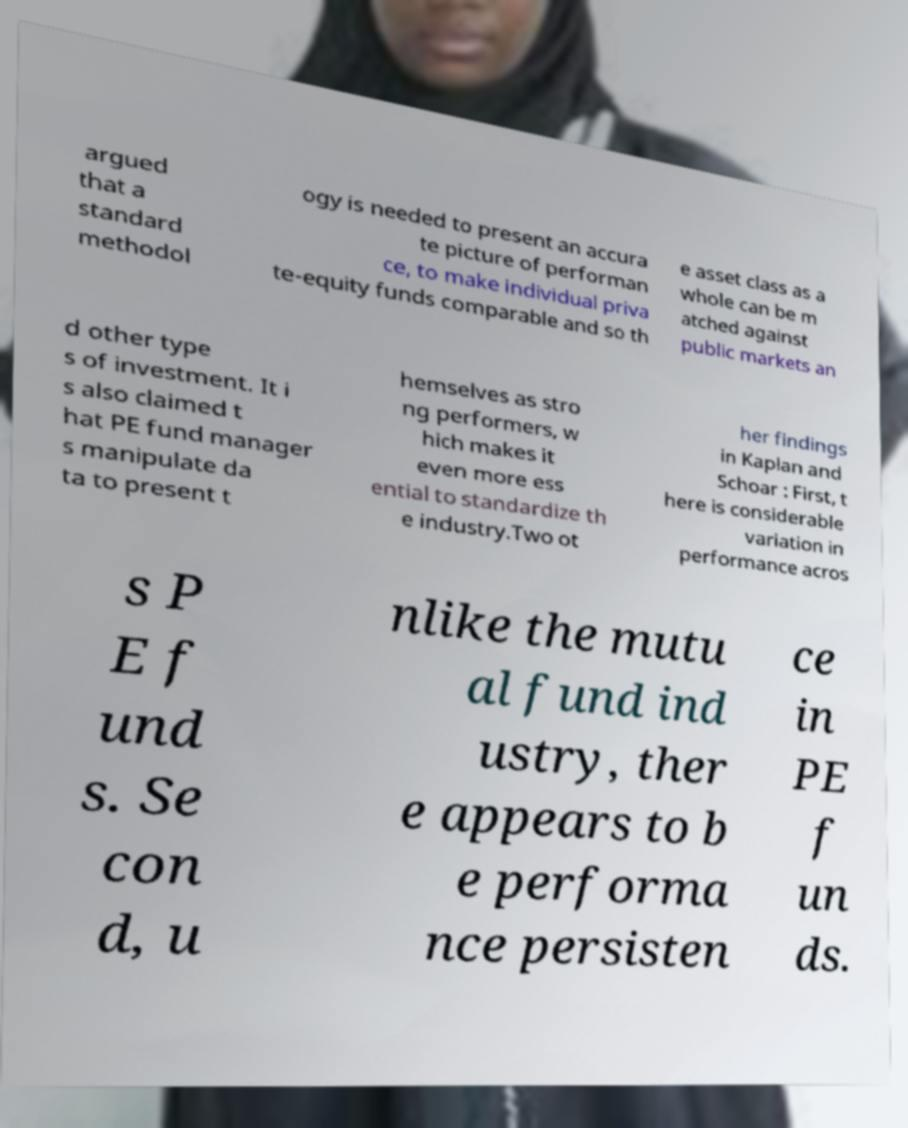Please identify and transcribe the text found in this image. argued that a standard methodol ogy is needed to present an accura te picture of performan ce, to make individual priva te-equity funds comparable and so th e asset class as a whole can be m atched against public markets an d other type s of investment. It i s also claimed t hat PE fund manager s manipulate da ta to present t hemselves as stro ng performers, w hich makes it even more ess ential to standardize th e industry.Two ot her findings in Kaplan and Schoar : First, t here is considerable variation in performance acros s P E f und s. Se con d, u nlike the mutu al fund ind ustry, ther e appears to b e performa nce persisten ce in PE f un ds. 